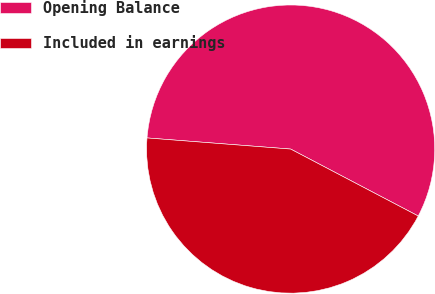<chart> <loc_0><loc_0><loc_500><loc_500><pie_chart><fcel>Opening Balance<fcel>Included in earnings<nl><fcel>56.46%<fcel>43.54%<nl></chart> 